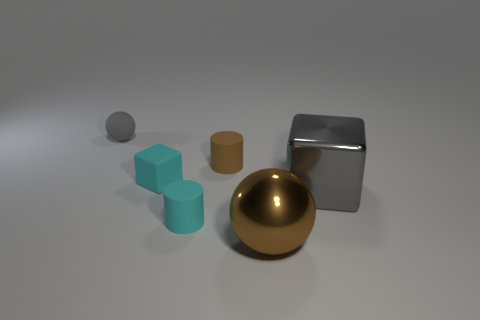Is the number of large gray blocks behind the tiny gray thing greater than the number of small cylinders behind the gray metal object?
Make the answer very short. No. How many other things are the same size as the cyan rubber block?
Offer a very short reply. 3. Does the sphere to the right of the gray rubber ball have the same color as the large block?
Offer a terse response. No. Is the number of tiny rubber cubes that are behind the brown cylinder greater than the number of big balls?
Your answer should be very brief. No. Is there any other thing of the same color as the tiny matte block?
Keep it short and to the point. Yes. There is a tiny cyan matte thing that is in front of the big metallic object behind the large shiny ball; what is its shape?
Offer a very short reply. Cylinder. Are there more large red rubber objects than cyan cylinders?
Offer a terse response. No. How many cyan matte objects are behind the gray metal thing and in front of the big shiny block?
Offer a terse response. 0. What number of small cyan matte cylinders are in front of the tiny cyan matte object that is in front of the gray metallic block?
Your answer should be compact. 0. What number of objects are objects on the left side of the gray metal cube or tiny cyan things that are behind the big gray cube?
Offer a very short reply. 5. 